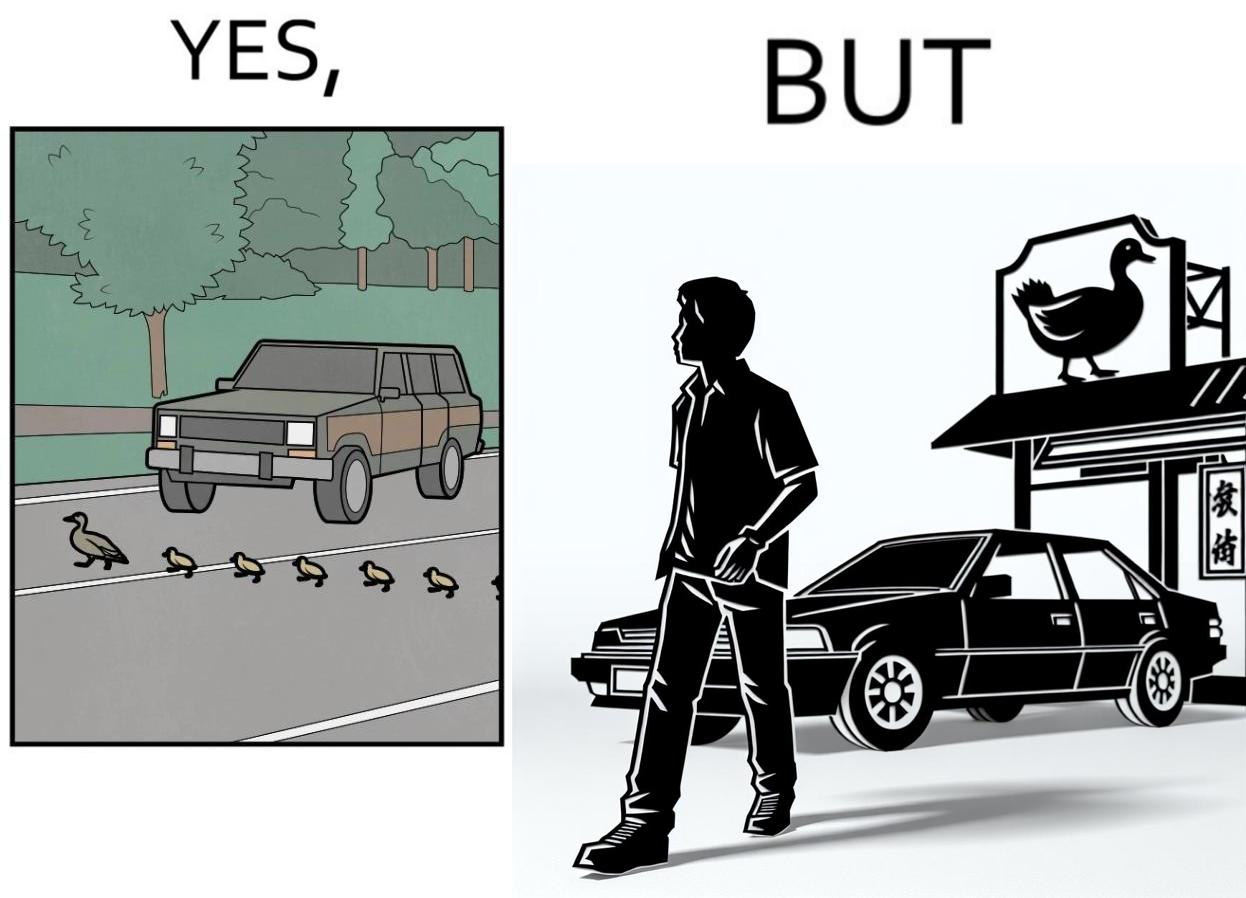Would you classify this image as satirical? Yes, this image is satirical. 